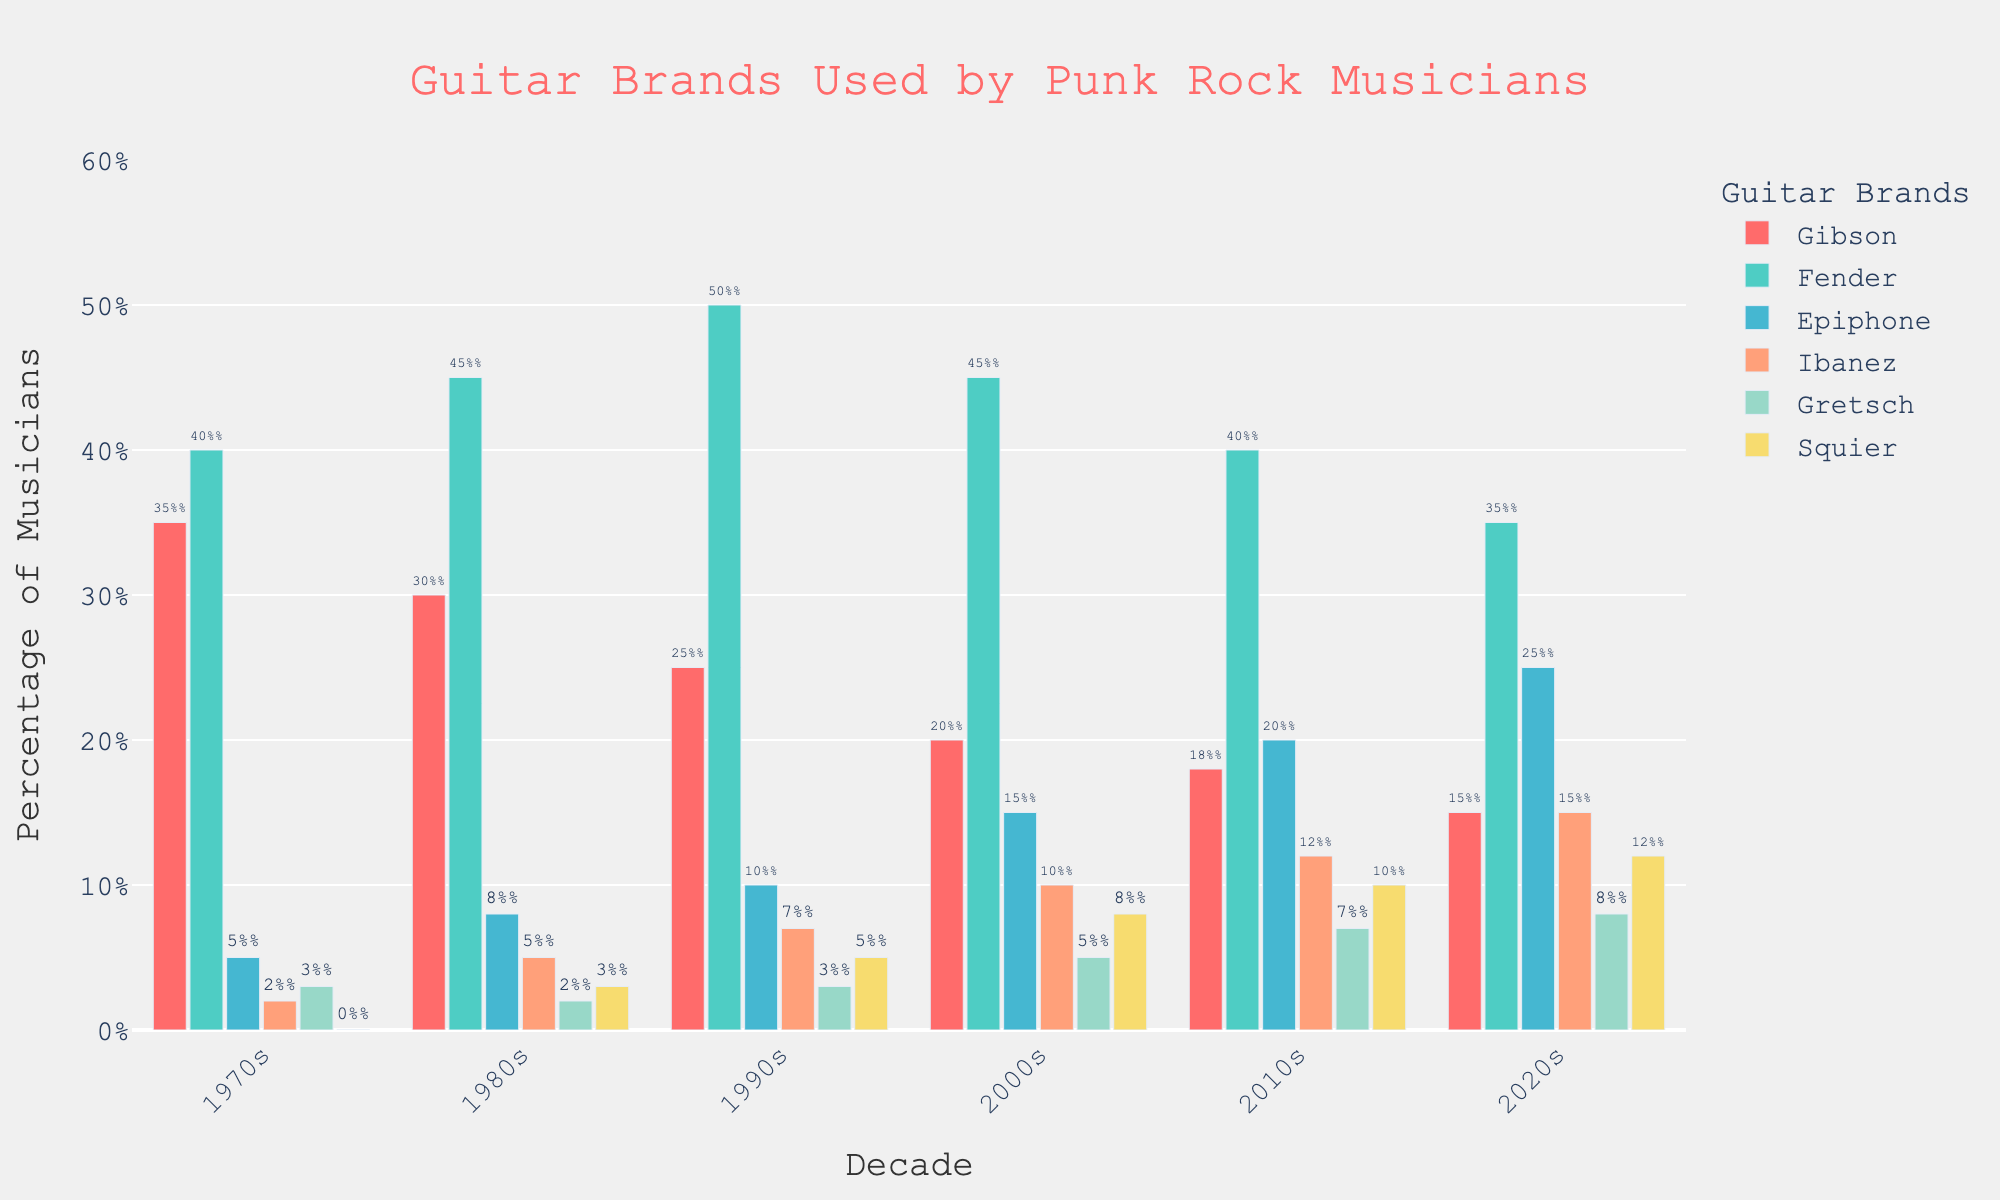How does the popularity of Fender guitars compare between the 1970s and the 2020s? In the 1970s, Fender guitars were used by 40% of punk rock musicians, while in the 2020s, they were used by 35%. To compare the popularity, you observe that the percentage decreased by 5% over these decades.
Answer: Fender guitars were used 5% less in the 2020s compared to the 1970s Which guitar brand had the highest increase in popularity from the 1970s to the 2020s? To find the highest increase, examine the percentages for each brand across the two decades. Epiphone increased from 5% in the 1970s to 25% in the 2020s, resulting in a 20% increase. This is the highest among all brands.
Answer: Epiphone What is the total percentage of musicians using Gibson and Ibanez guitars in the 2010s? Look at the 2010s data: Gibson (18%) and Ibanez (12%). Add these percentages to find the total percentage of musicians using these brands in that decade. 18% + 12% = 30%
Answer: 30% Which brand showed a continuous increase in usage across all decades? Analyzing the year-by-year data for each brand, Epiphone consistently increased from 5% in the 1970s to 25% in the 2020s without any dips.
Answer: Epiphone How do Epiphone and Squier guitars' popularity compare in the 2020s? In the 2020s, the bar chart shows that Epiphone guitars have a usage percentage of 25%, while Squier has 12%. Epiphone is more popular by 13%.
Answer: Epiphone is 13% more popular From which decade did Ibanez guitars start gaining noticeable popularity? Review the percentages: Ibanez has 2% in the 1970s, 5% in the 1980s, and 7% in the 1990s. The first significant jump is in the 1990s with 7%.
Answer: 1990s Calculate the average percentage of musicians using Gretsch guitars from the 1970s to the 2020s. Check the percentages: 1970s (3%), 1980s (2%), 1990s (3%), 2000s (5%), 2010s (7%), 2020s (8%). Add these values and divide by six decades to get the average: (3 + 2 + 3 + 5 + 7 + 8) / 6 = 4.67%
Answer: 4.67% Which decade saw the highest popularity of Gibson guitars and what was the percentage? By checking the chart, Gibson guitars were most popular in the 1970s with a usage of 35%.
Answer: 1970s with 35% When did Squier guitars first become notably used by punk rock musicians? Observing the chart, Squier guitars start appearing in the 1980s with 3% usage, which is the first noticeable usage.
Answer: 1980s What is the difference in popularity between the most and least used guitar brands in the 2000s? In the 2000s, the highest percentage is for Fender (45%) and the lowest is for Gibson (20%). The difference is 45% - 20% = 25%.
Answer: 25% 